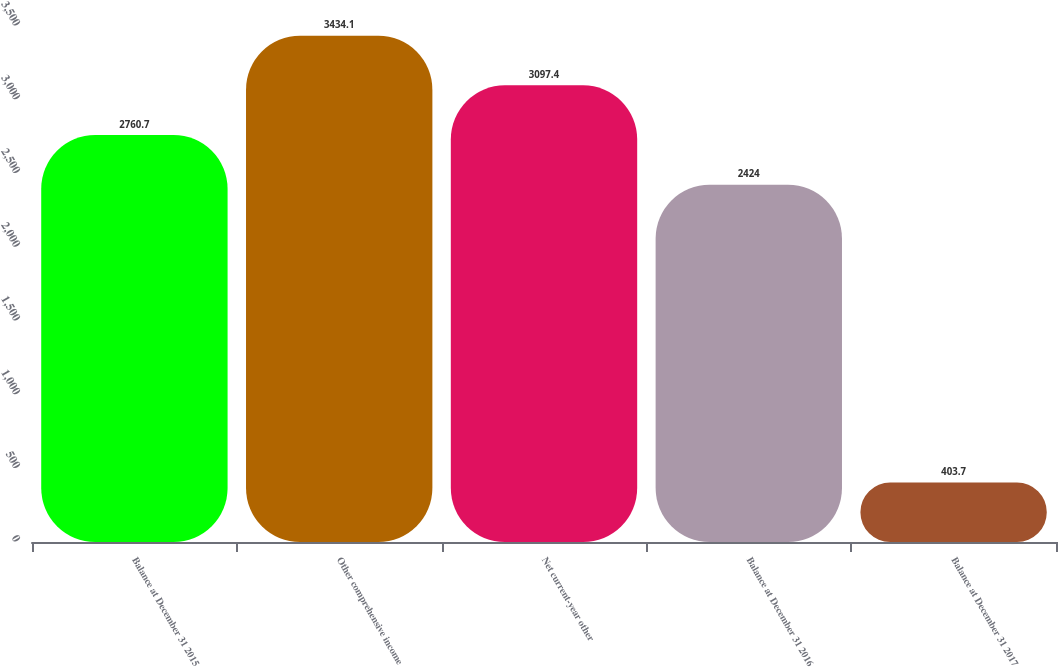<chart> <loc_0><loc_0><loc_500><loc_500><bar_chart><fcel>Balance at December 31 2015<fcel>Other comprehensive income<fcel>Net current-year other<fcel>Balance at December 31 2016<fcel>Balance at December 31 2017<nl><fcel>2760.7<fcel>3434.1<fcel>3097.4<fcel>2424<fcel>403.7<nl></chart> 